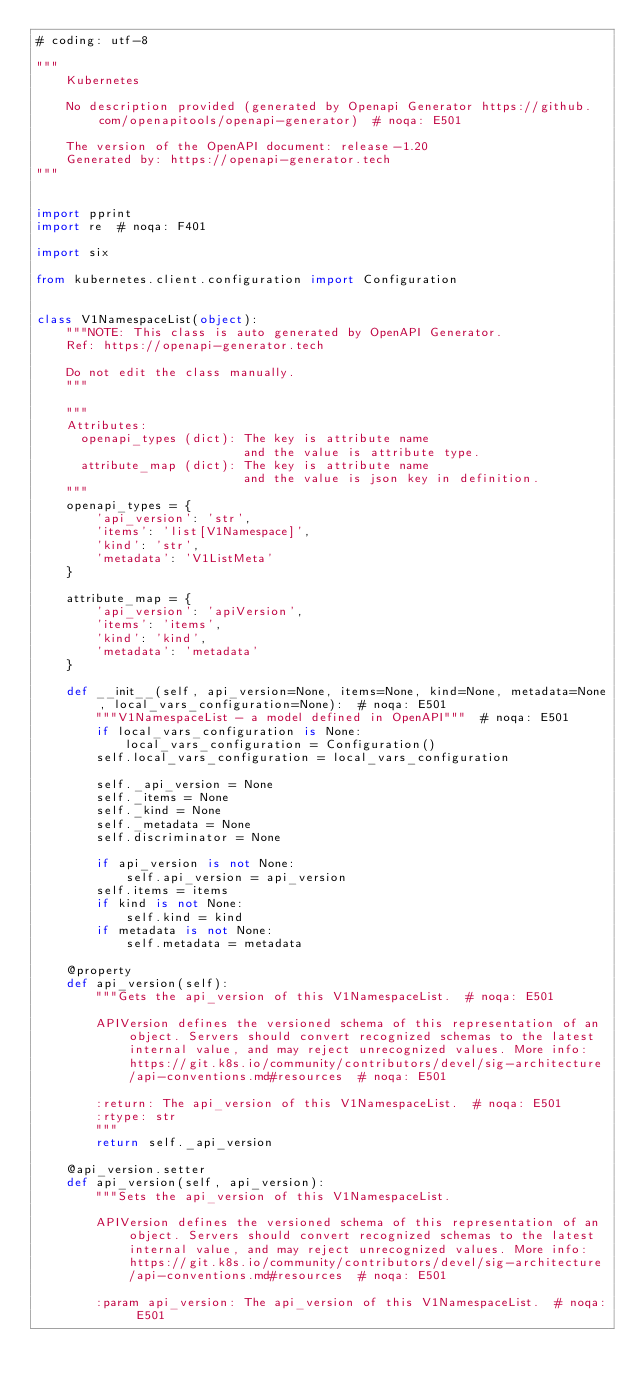<code> <loc_0><loc_0><loc_500><loc_500><_Python_># coding: utf-8

"""
    Kubernetes

    No description provided (generated by Openapi Generator https://github.com/openapitools/openapi-generator)  # noqa: E501

    The version of the OpenAPI document: release-1.20
    Generated by: https://openapi-generator.tech
"""


import pprint
import re  # noqa: F401

import six

from kubernetes.client.configuration import Configuration


class V1NamespaceList(object):
    """NOTE: This class is auto generated by OpenAPI Generator.
    Ref: https://openapi-generator.tech

    Do not edit the class manually.
    """

    """
    Attributes:
      openapi_types (dict): The key is attribute name
                            and the value is attribute type.
      attribute_map (dict): The key is attribute name
                            and the value is json key in definition.
    """
    openapi_types = {
        'api_version': 'str',
        'items': 'list[V1Namespace]',
        'kind': 'str',
        'metadata': 'V1ListMeta'
    }

    attribute_map = {
        'api_version': 'apiVersion',
        'items': 'items',
        'kind': 'kind',
        'metadata': 'metadata'
    }

    def __init__(self, api_version=None, items=None, kind=None, metadata=None, local_vars_configuration=None):  # noqa: E501
        """V1NamespaceList - a model defined in OpenAPI"""  # noqa: E501
        if local_vars_configuration is None:
            local_vars_configuration = Configuration()
        self.local_vars_configuration = local_vars_configuration

        self._api_version = None
        self._items = None
        self._kind = None
        self._metadata = None
        self.discriminator = None

        if api_version is not None:
            self.api_version = api_version
        self.items = items
        if kind is not None:
            self.kind = kind
        if metadata is not None:
            self.metadata = metadata

    @property
    def api_version(self):
        """Gets the api_version of this V1NamespaceList.  # noqa: E501

        APIVersion defines the versioned schema of this representation of an object. Servers should convert recognized schemas to the latest internal value, and may reject unrecognized values. More info: https://git.k8s.io/community/contributors/devel/sig-architecture/api-conventions.md#resources  # noqa: E501

        :return: The api_version of this V1NamespaceList.  # noqa: E501
        :rtype: str
        """
        return self._api_version

    @api_version.setter
    def api_version(self, api_version):
        """Sets the api_version of this V1NamespaceList.

        APIVersion defines the versioned schema of this representation of an object. Servers should convert recognized schemas to the latest internal value, and may reject unrecognized values. More info: https://git.k8s.io/community/contributors/devel/sig-architecture/api-conventions.md#resources  # noqa: E501

        :param api_version: The api_version of this V1NamespaceList.  # noqa: E501</code> 